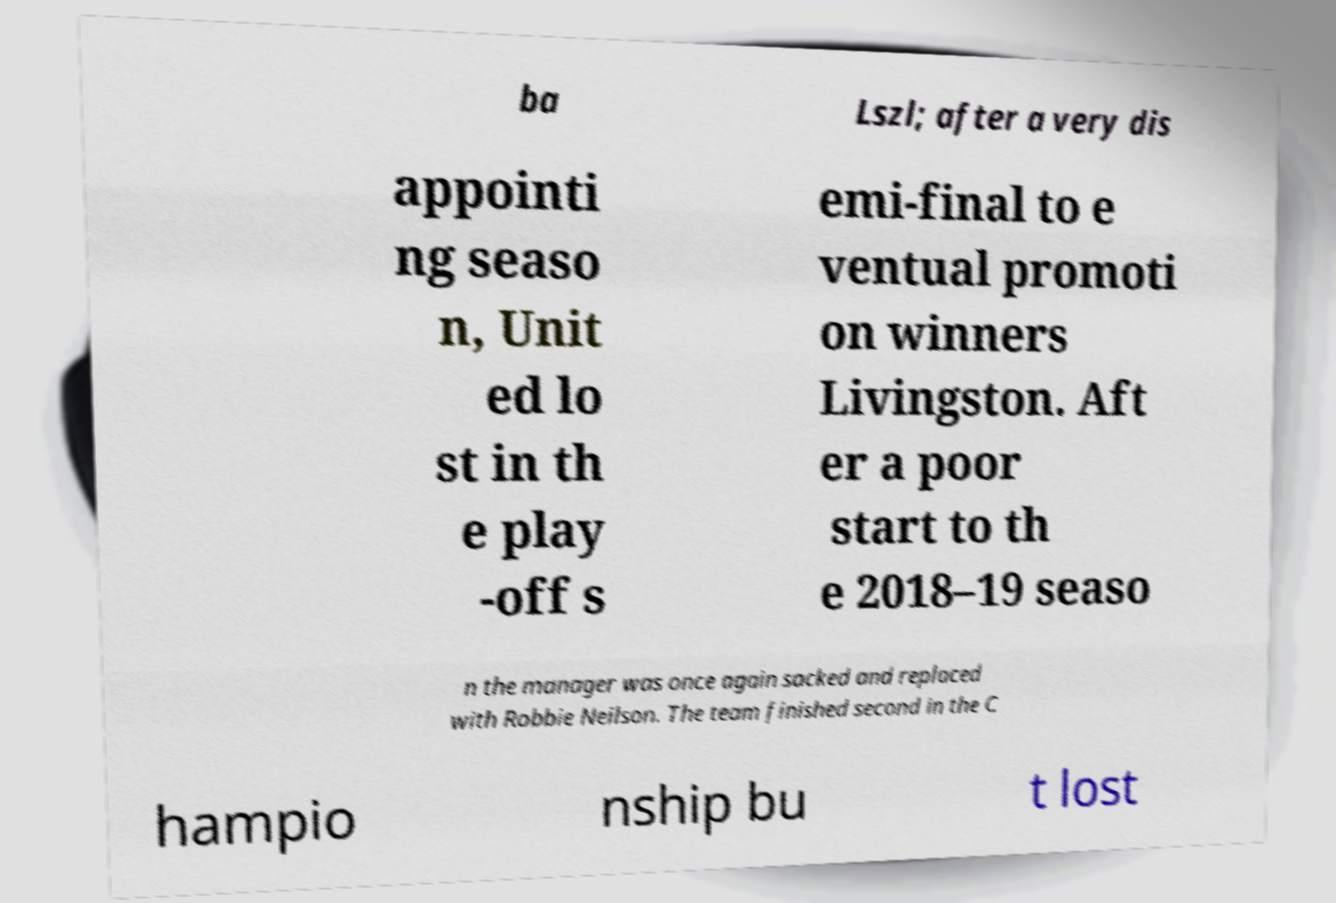What messages or text are displayed in this image? I need them in a readable, typed format. ba Lszl; after a very dis appointi ng seaso n, Unit ed lo st in th e play -off s emi-final to e ventual promoti on winners Livingston. Aft er a poor start to th e 2018–19 seaso n the manager was once again sacked and replaced with Robbie Neilson. The team finished second in the C hampio nship bu t lost 